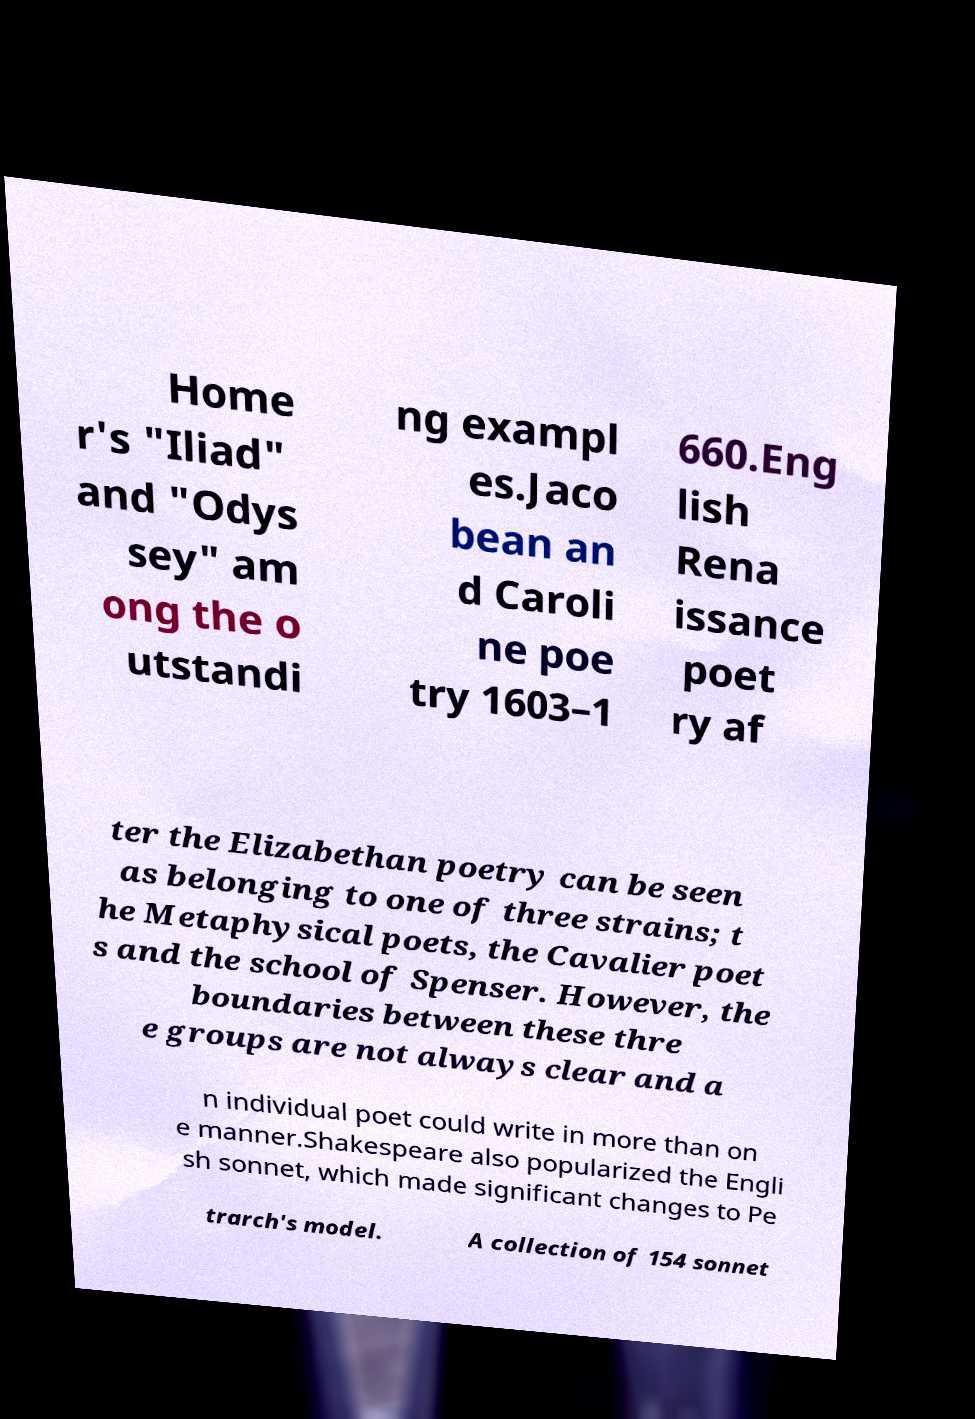Please identify and transcribe the text found in this image. Home r's "Iliad" and "Odys sey" am ong the o utstandi ng exampl es.Jaco bean an d Caroli ne poe try 1603–1 660.Eng lish Rena issance poet ry af ter the Elizabethan poetry can be seen as belonging to one of three strains; t he Metaphysical poets, the Cavalier poet s and the school of Spenser. However, the boundaries between these thre e groups are not always clear and a n individual poet could write in more than on e manner.Shakespeare also popularized the Engli sh sonnet, which made significant changes to Pe trarch's model. A collection of 154 sonnet 